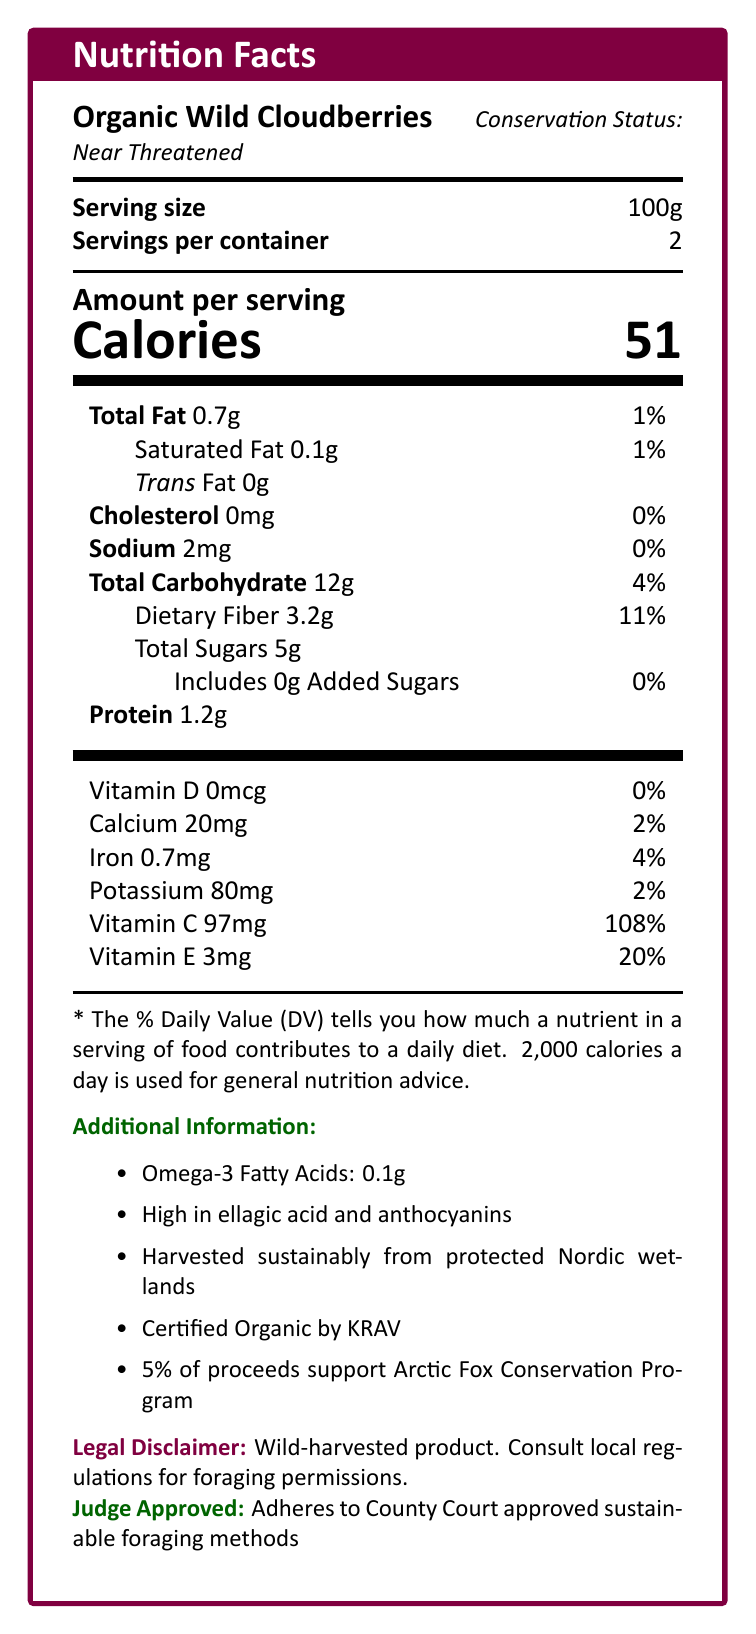what is the total fat content per serving? The total fat content per serving is listed as 0.7g in the "Total Fat" section of the document.
Answer: 0.7g how many calories are in one container? Each serving is 51 calories, and there are 2 servings per container, so 51 x 2 = 102 calories.
Answer: 102 what is the conservation status of the cloudberries? The conservation status is explicitly mentioned as "Near Threatened" in the document.
Answer: Near Threatened is there any added sugar in the cloudberries? The document states that the added sugars are 0g.
Answer: No what percentage of daily vitamin C does a serving provide? A serving provides 97mg of vitamin C, which is 108% of the daily value.
Answer: 108% to which certification does this product adhere? A. USDA Organic B. ECOCERT C. KRAV D. Fair Trade The document mentions "Certified Organic by KRAV".
Answer: C which nutrient has the highest percentage of daily value? A. Vitamin D B. Vitamin C C. Calcium D. Potassium Vitamin C has the highest percentage, 108%.
Answer: B is this product harvested sustainably? The document states that the product is "Harvested sustainably from protected Nordic wetlands".
Answer: Yes does the product support any wildlife conservation programs? 5% of proceeds support the Arctic Fox Conservation Program.
Answer: Yes summarize the main idea of the document. The document is a detailed Nutrition Facts label for Organic Wild Cloudberries, featuring nutritional values per serving, sustainability and certification claims, and contributions to conservation efforts. It also includes additional information about omega-3 fatty acids, antioxidants, legal disclaimers, and judge-approved harvesting practices.
Answer: The document provides comprehensive nutritional information for Organic Wild Cloudberries, highlights sustainable harvesting practices, outlines its conservation status, and mentions certifications and contributions to wildlife conservation programs. how much vitamin E does each serving contain? The document lists 3mg of vitamin E per serving.
Answer: 3mg is this product high in sodium? The sodium content is 2mg, which is 0% of the daily value, thus it is not high in sodium.
Answer: No who approved the sustainable foraging methods? The document states that it adheres to County Court approved sustainable foraging methods.
Answer: County Court can I eat this product if I follow a cholesterol-free diet? The document lists 0mg of cholesterol per serving.
Answer: Yes how many grams of protein are in a serving? The protein content per serving is 1.2g.
Answer: 1.2g are cloudberries a good source of dietary fiber? Each serving contains 3.2g of dietary fiber, which is 11% of the daily value, indicating they are a good source of dietary fiber.
Answer: Yes does the product contain any omega-3 fatty acids? The product contains 0.1g of omega-3 fatty acids per serving.
Answer: Yes what kind of antioxidants are high in this product? The document mentions that the product is high in "ellagic acid and anthocyanins".
Answer: Ellagic acid and anthocyanins what is the sugar content for the entire container? Each serving contains 5g of sugars, and there are 2 servings per container, so 5 x 2 = 10g.
Answer: 10g can the nutritional values of this product help support a low-fat diet? With only 0.7g of total fat and 0.1g of saturated fat per serving, this product is suitable for a low-fat diet.
Answer: Yes what is the foraging regulation status of this product? The document advises consulting local regulations for foraging permissions but does not provide specific details on foraging regulations.
Answer: Not enough information is vitamin D present in this product? The document lists 0mcg of vitamin D, indicating absence of vitamin D in the product.
Answer: No 